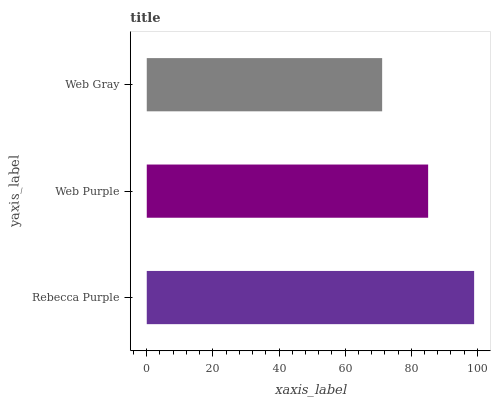Is Web Gray the minimum?
Answer yes or no. Yes. Is Rebecca Purple the maximum?
Answer yes or no. Yes. Is Web Purple the minimum?
Answer yes or no. No. Is Web Purple the maximum?
Answer yes or no. No. Is Rebecca Purple greater than Web Purple?
Answer yes or no. Yes. Is Web Purple less than Rebecca Purple?
Answer yes or no. Yes. Is Web Purple greater than Rebecca Purple?
Answer yes or no. No. Is Rebecca Purple less than Web Purple?
Answer yes or no. No. Is Web Purple the high median?
Answer yes or no. Yes. Is Web Purple the low median?
Answer yes or no. Yes. Is Web Gray the high median?
Answer yes or no. No. Is Web Gray the low median?
Answer yes or no. No. 